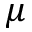Convert formula to latex. <formula><loc_0><loc_0><loc_500><loc_500>\mu</formula> 